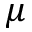Convert formula to latex. <formula><loc_0><loc_0><loc_500><loc_500>\mu</formula> 